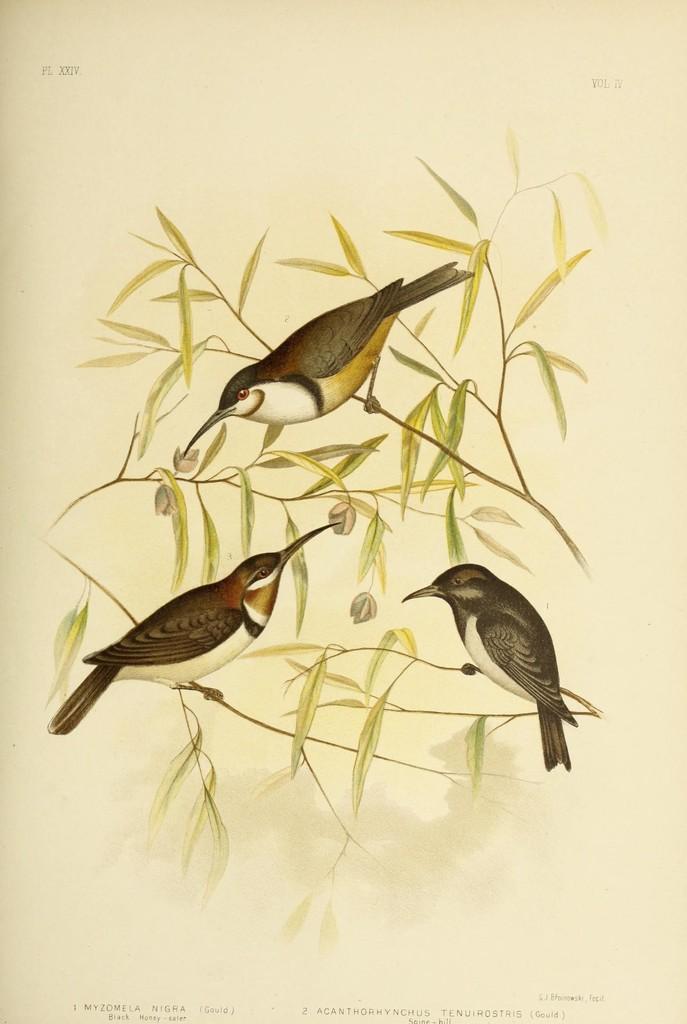Could you give a brief overview of what you see in this image? In this image there is a painting of birds on branches with leaves. 